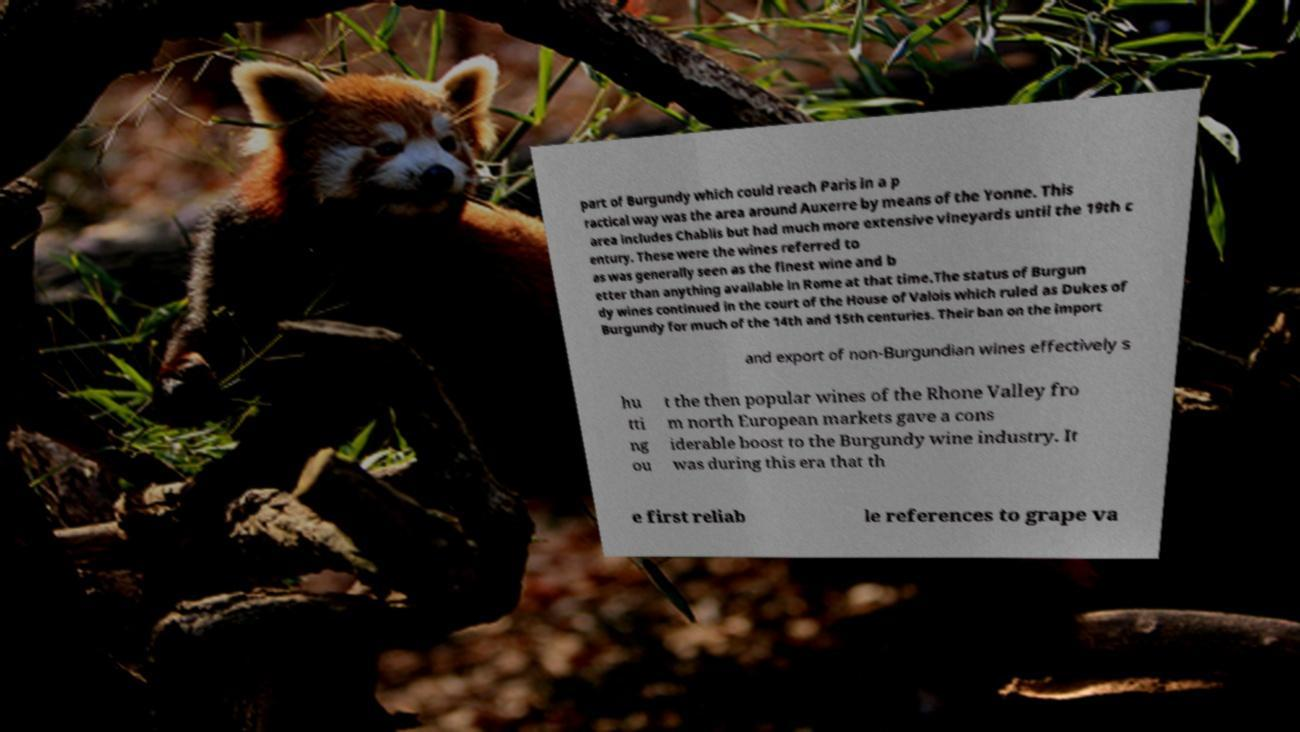Could you extract and type out the text from this image? part of Burgundy which could reach Paris in a p ractical way was the area around Auxerre by means of the Yonne. This area includes Chablis but had much more extensive vineyards until the 19th c entury. These were the wines referred to as was generally seen as the finest wine and b etter than anything available in Rome at that time.The status of Burgun dy wines continued in the court of the House of Valois which ruled as Dukes of Burgundy for much of the 14th and 15th centuries. Their ban on the import and export of non-Burgundian wines effectively s hu tti ng ou t the then popular wines of the Rhone Valley fro m north European markets gave a cons iderable boost to the Burgundy wine industry. It was during this era that th e first reliab le references to grape va 